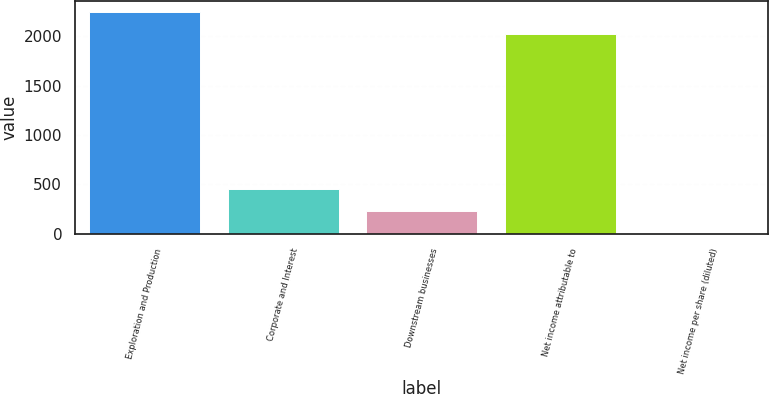<chart> <loc_0><loc_0><loc_500><loc_500><bar_chart><fcel>Exploration and Production<fcel>Corporate and Interest<fcel>Downstream businesses<fcel>Net income attributable to<fcel>Net income per share (diluted)<nl><fcel>2245.61<fcel>451.61<fcel>231<fcel>2025<fcel>5.95<nl></chart> 